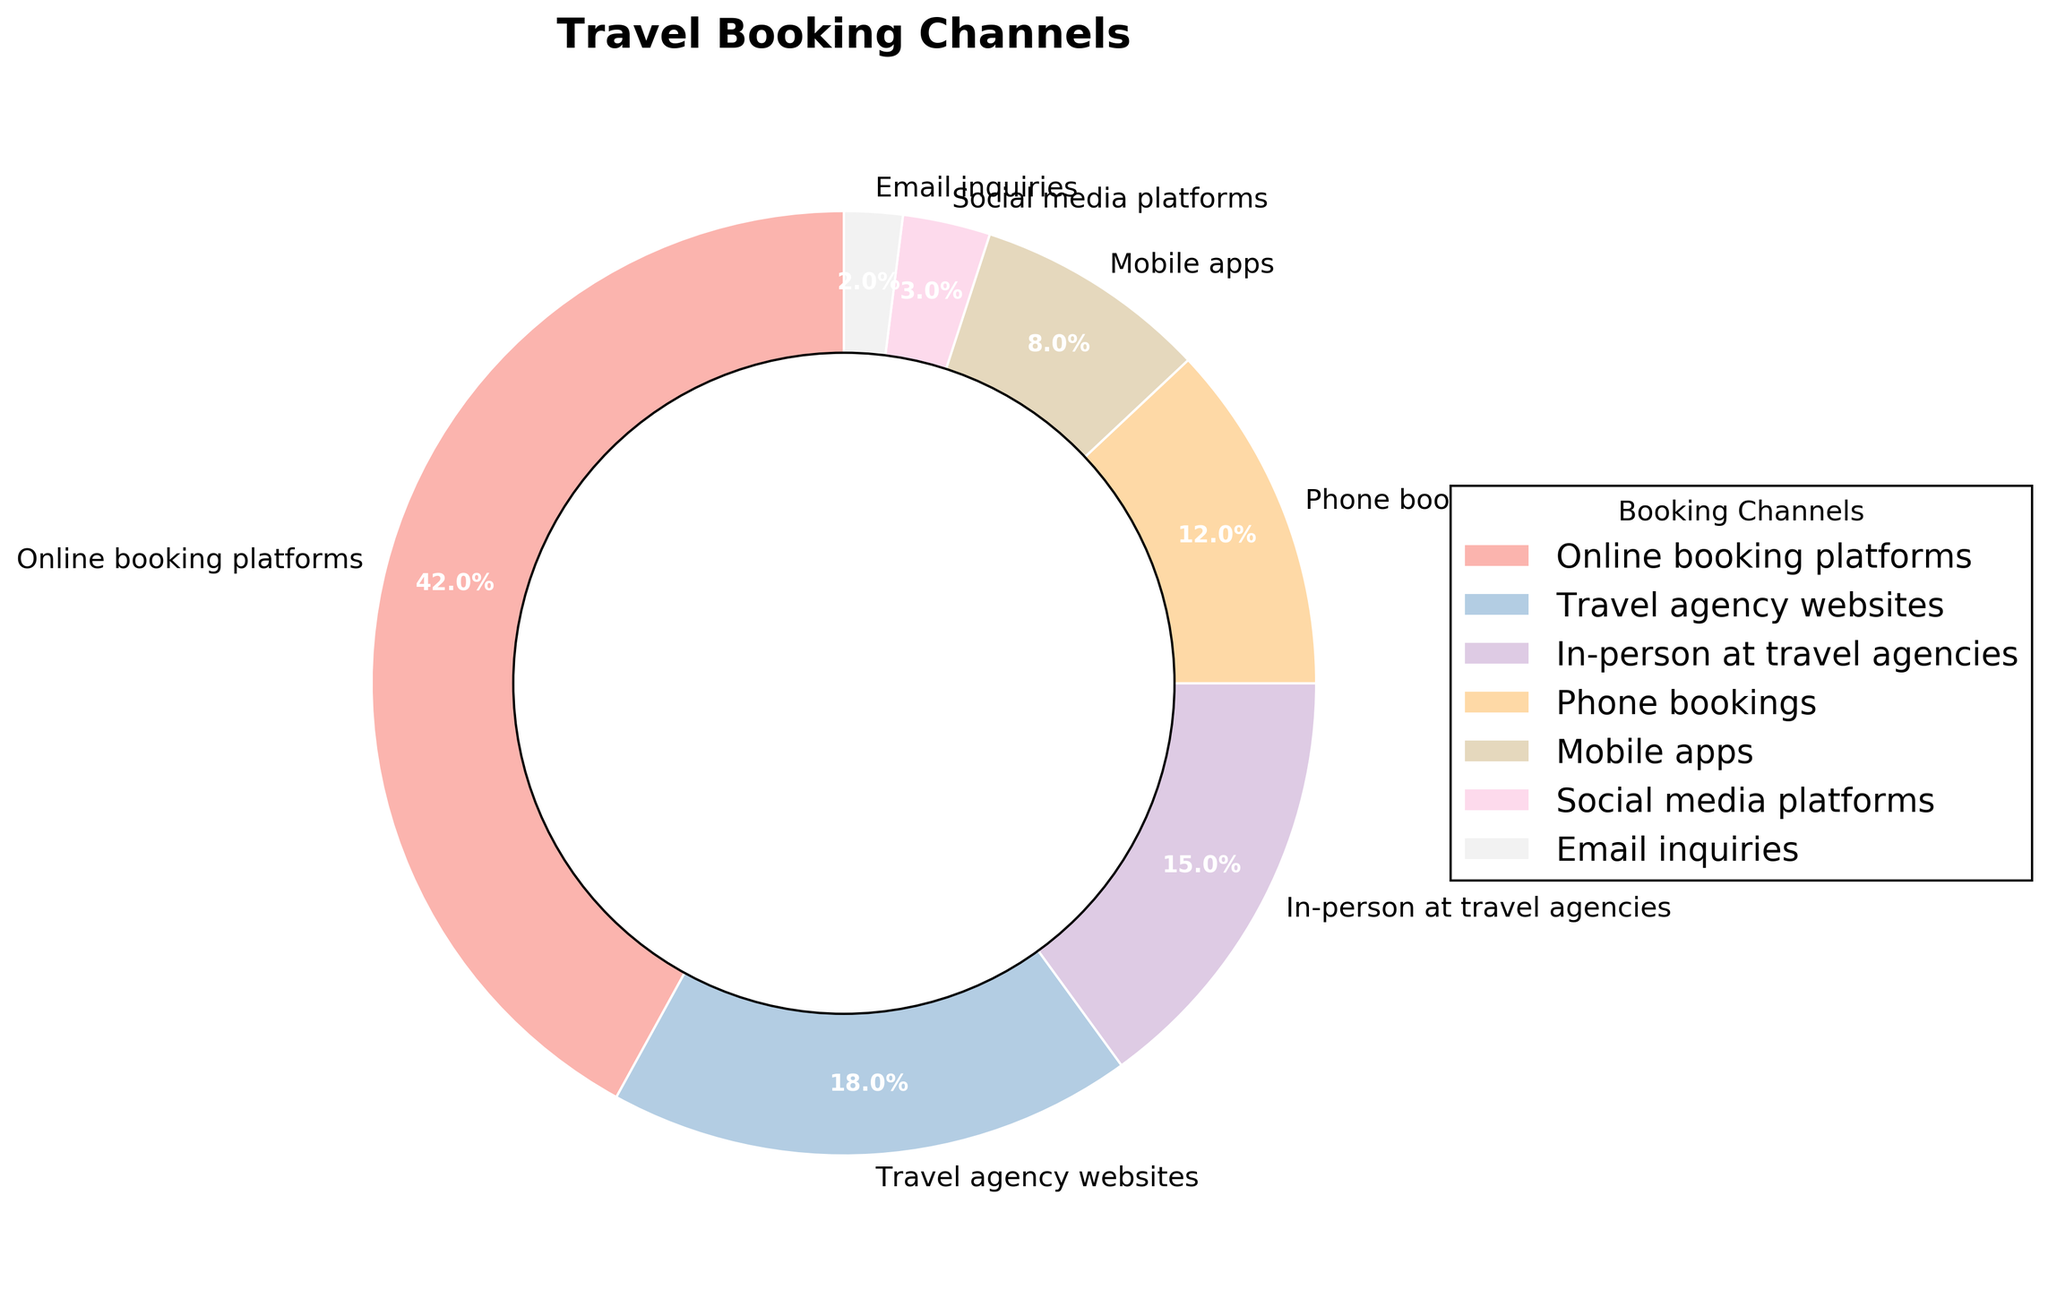Which booking channel has the highest percentage of travel bookings? Look at the segment with the largest size in the pie chart and read its label.
Answer: Online booking platforms What is the combined percentage of travel bookings made through phone and in-person at travel agencies? Add the percentages of phone bookings (12%) and in-person at travel agencies (15%). 12% + 15% = 27%.
Answer: 27% Are there more bookings made through mobile apps or through email inquiries? Compare the sizes of the segments for mobile apps (8%) and email inquiries (2%). 8% is greater than 2%.
Answer: Mobile apps Which booking channels make up less than 10% of the total bookings each? Identify the segments with percentages less than 10%. These are mobile apps (8%), social media platforms (3%), and email inquiries (2%).
Answer: Mobile apps, social media platforms, email inquiries What is the percentage difference between travel agency websites and social media platforms? Subtract the percentage of social media platforms (3%) from travel agency websites (18%). 18% - 3% = 15%.
Answer: 15% What is the total percentage of bookings made through online channels (online booking platforms, travel agency websites, mobile apps, social media platforms, email inquiries)? Sum the percentages of the relevant channels: 42% (online booking platforms) + 18% (travel agency websites) + 8% (mobile apps) + 3% (social media platforms) + 2% (email inquiries). 42% + 18% + 8% + 3% + 2% = 73%.
Answer: 73% Which booking channel has the smallest percentage share? Identify the segment with the smallest size in the pie chart and read its label.
Answer: Email inquiries Is the percentage of travel bookings through social media platforms more than double that of email inquiries? Calculate the double of the email inquiries percentage (2% * 2 = 4%) and compare it with social media platforms percentage (3%). 3% is less than 4%.
Answer: No What visual attribute helps in distinguishing the different booking channels on the pie chart? The pie chart segments are distinguished by different colors.
Answer: Colors How do phone bookings compare to in-person bookings at travel agencies in terms of percentage points? Subtract the percentage of phone bookings (12%) from the in-person bookings at travel agencies (15%). 15% - 12% = 3%.
Answer: In-person bookings are 3% more 